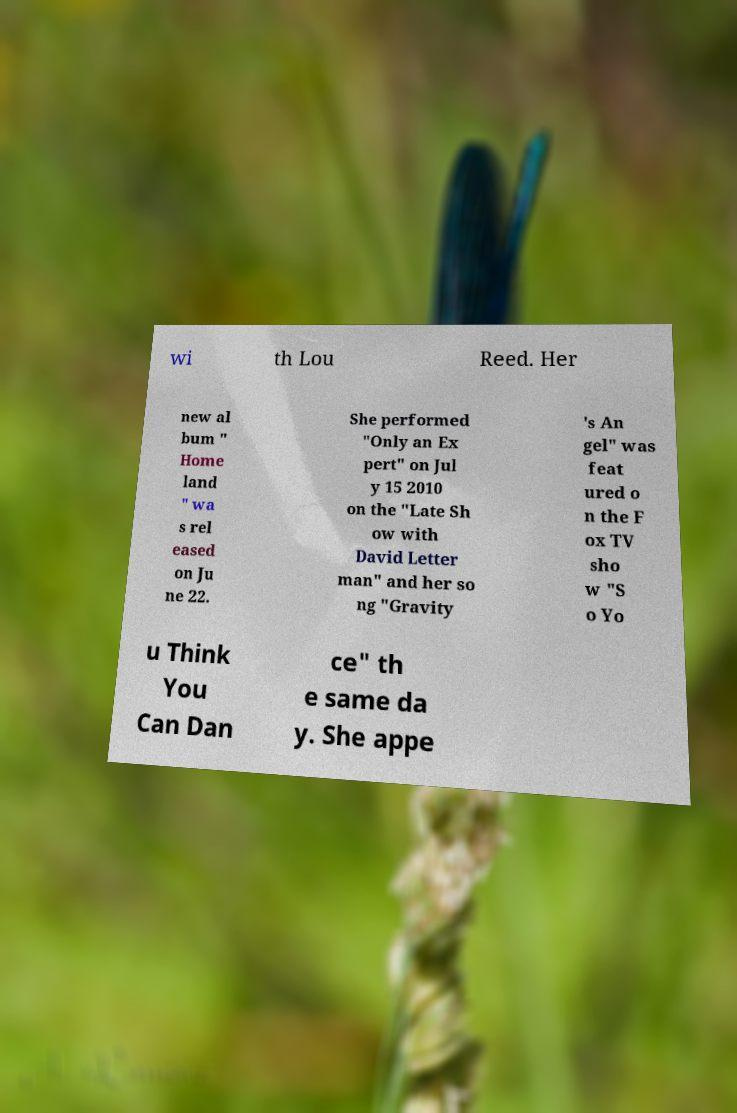Please read and relay the text visible in this image. What does it say? wi th Lou Reed. Her new al bum " Home land " wa s rel eased on Ju ne 22. She performed "Only an Ex pert" on Jul y 15 2010 on the "Late Sh ow with David Letter man" and her so ng "Gravity 's An gel" was feat ured o n the F ox TV sho w "S o Yo u Think You Can Dan ce" th e same da y. She appe 